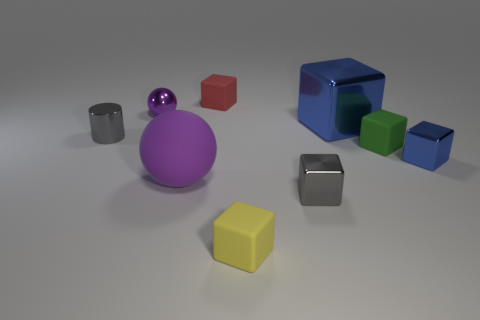What colors can you see in the image, and how many objects of each color are there? In the image, there's a variety of colors visible. There's one large purple sphere, one small purple sphere, one red cube, one yellow cube, two small gray metallic items, one large blue cube, and two green cubes. Therefore, we have purple items in two sizes, a single red item, one yellow, two gray of a smaller size, one large blue, and two green items. 